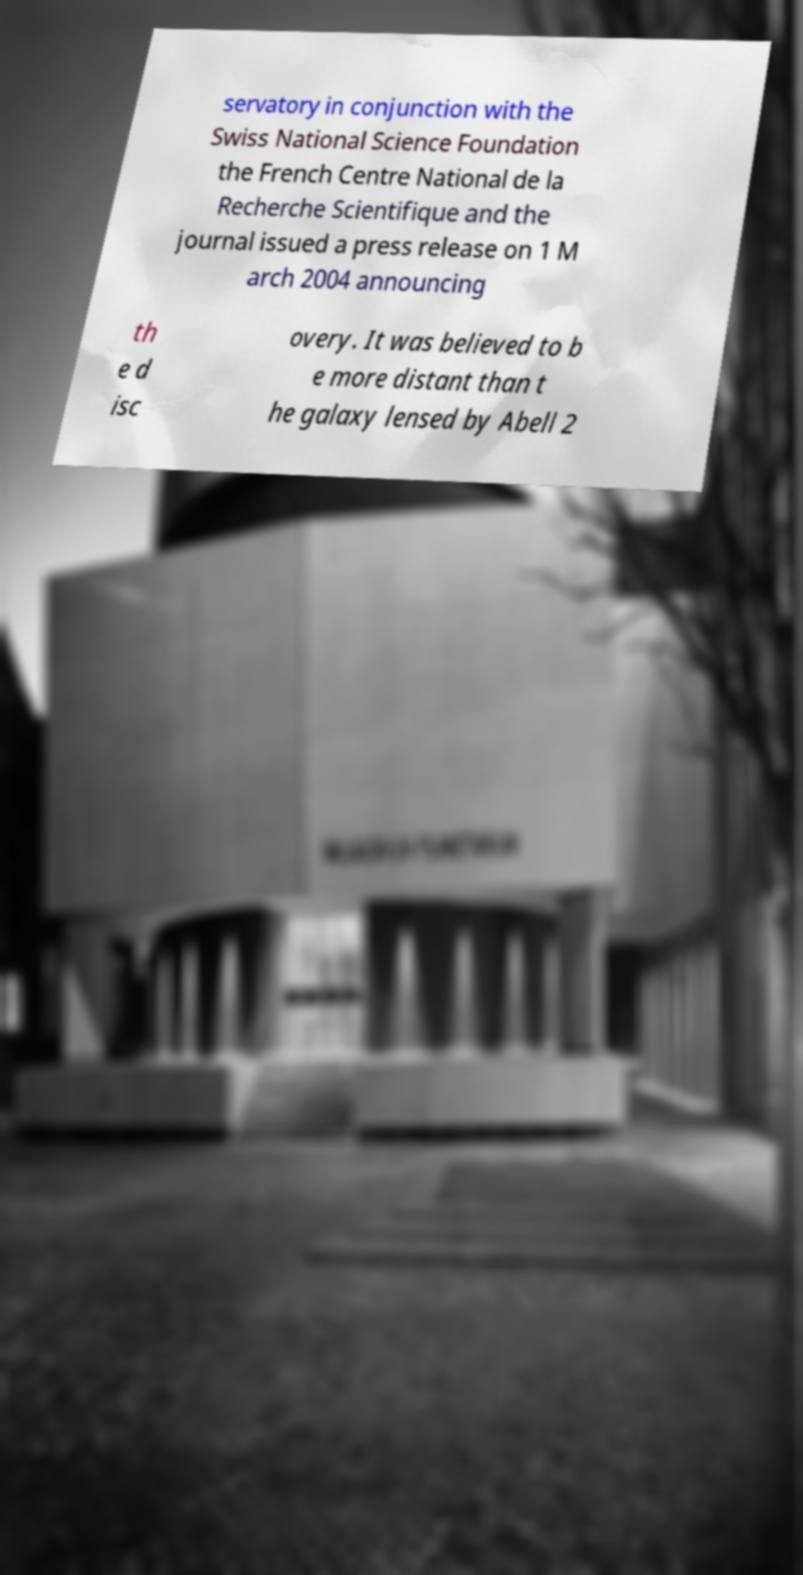What messages or text are displayed in this image? I need them in a readable, typed format. servatory in conjunction with the Swiss National Science Foundation the French Centre National de la Recherche Scientifique and the journal issued a press release on 1 M arch 2004 announcing th e d isc overy. It was believed to b e more distant than t he galaxy lensed by Abell 2 